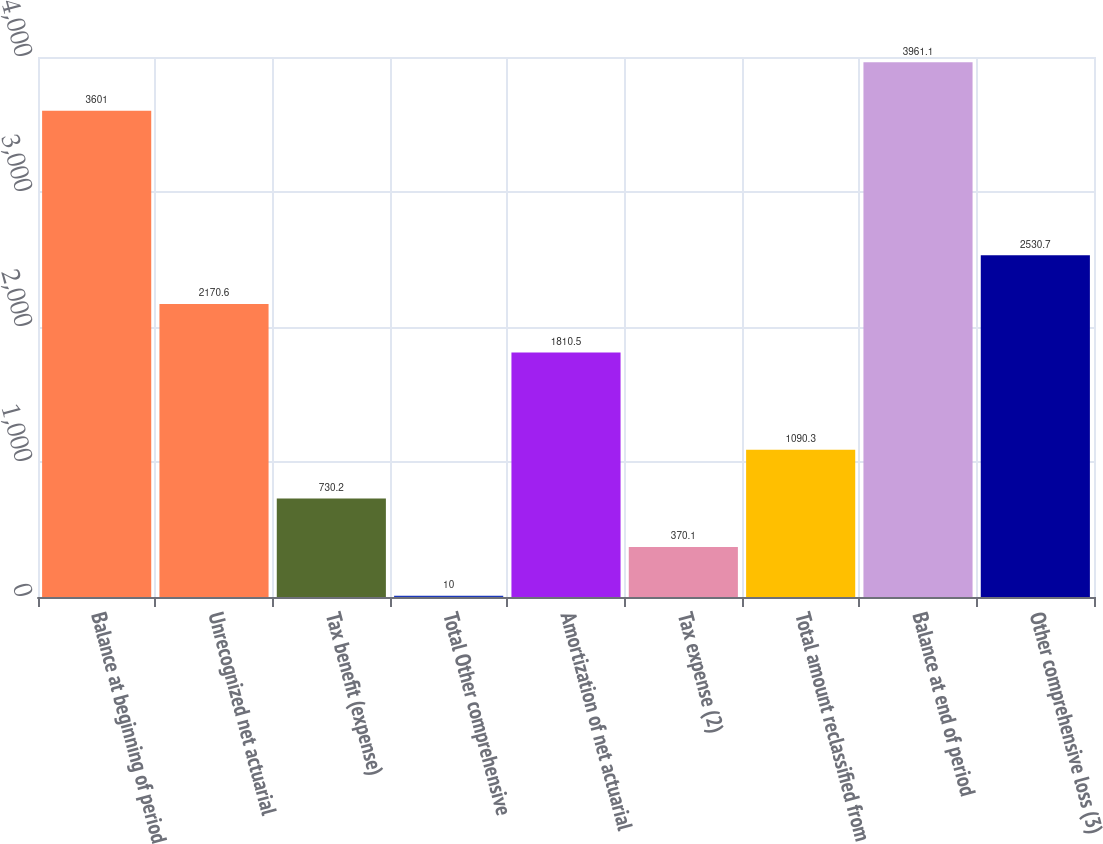<chart> <loc_0><loc_0><loc_500><loc_500><bar_chart><fcel>Balance at beginning of period<fcel>Unrecognized net actuarial<fcel>Tax benefit (expense)<fcel>Total Other comprehensive<fcel>Amortization of net actuarial<fcel>Tax expense (2)<fcel>Total amount reclassified from<fcel>Balance at end of period<fcel>Other comprehensive loss (3)<nl><fcel>3601<fcel>2170.6<fcel>730.2<fcel>10<fcel>1810.5<fcel>370.1<fcel>1090.3<fcel>3961.1<fcel>2530.7<nl></chart> 